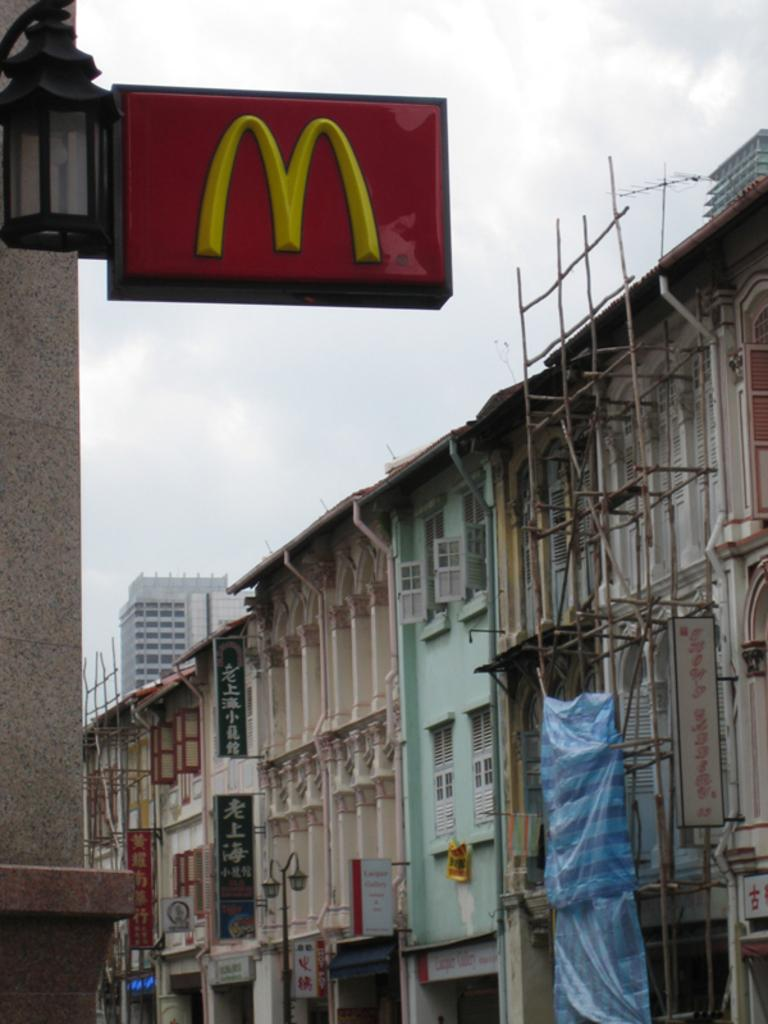What type of structures are located at the bottom of the image? There are buildings at the bottom of the image. What can be seen in the background of the image? The sky is visible in the background of the image. What is located at the top of the image? There is a board at the top of the image. Where is the pump located in the image? There is no pump present in the image. What time is displayed on the clock in the image? There is no clock present in the image. 